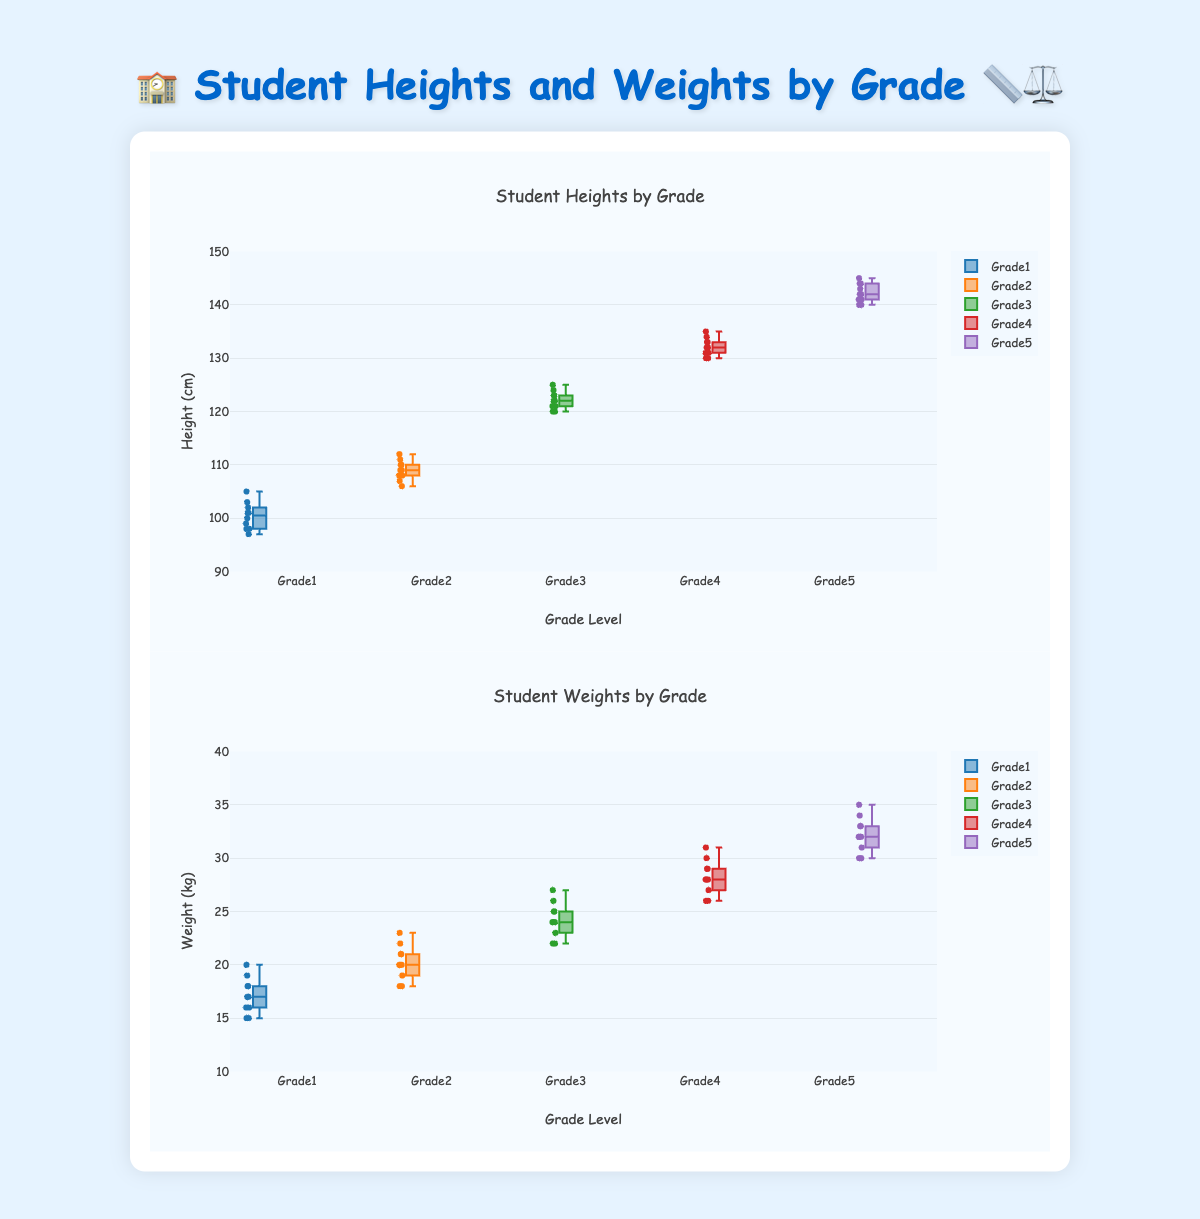What is the title of the first box plot? The title of a box plot is usually displayed at the top of the plot. Refer to the top of the "heightPlot" box plot to find this information.
Answer: Student Heights by Grade What are the units of measurement on the y-axis of the first box plot? The y-axis label usually tells us the unit of measurement. Look at the label next to the y-axis on the "heightPlot" box plot.
Answer: Height (cm) Which grade has the tallest student? To find the tallest student, identify the highest data point in the "heightPlot" box plot. The tallest data point is in Grade 5, reaching up to 145 cm.
Answer: Grade 5 What is the range of weights for Grade 3 students? To find the range, look at the lowest and highest data points for Grade 3 in the "weightPlot" box plot. The range is from 22 kg to 27 kg.
Answer: 22 kg to 27 kg Compare the median height of Grade 1 and Grade 3. Which grade has a higher median height? The median is marked by the line within each box. Compare the median lines of Grade 1 and Grade 3 in the "heightPlot" box plot. Median height in Grade 3 is higher than in Grade 1.
Answer: Grade 3 Which grade shows the greatest variability in student weights? Variability is indicated by the length of the box and the whiskers in a box plot. Look at the "weightPlot" and compare the box lengths across grades. Grade 5 shows the greatest variability.
Answer: Grade 5 What is the interquartile range (IQR) of heights for Grade 4? The IQR is the difference between the third quartile (75th percentile) and the first quartile (25th percentile). In the "heightPlot" for Grade 4, approximate these values and calculate the IQR. IQR is 133 - 131 = 2 cm.
Answer: 2 cm Are the weights of students in Grade 2 generally higher than those in Grade 1? Compare the median lines in the "weightPlot" for Grade 2 and Grade 1. The median weight in Grade 2 is higher than in Grade 1.
Answer: Yes What is the maximum height observed for Grade 1 students? To find the maximum height, locate the highest data point in the "heightPlot" for Grade 1. This point reaches 105 cm.
Answer: 105 cm Is there any overlap in the heights of students from Grade 2 and Grade 3? Overlap occurs if the whiskers or boxes extend into the same range. In the "heightPlot", check if the Grade 2 and Grade 3 boxes overlap. They do, around the height of 123 cm.
Answer: Yes 